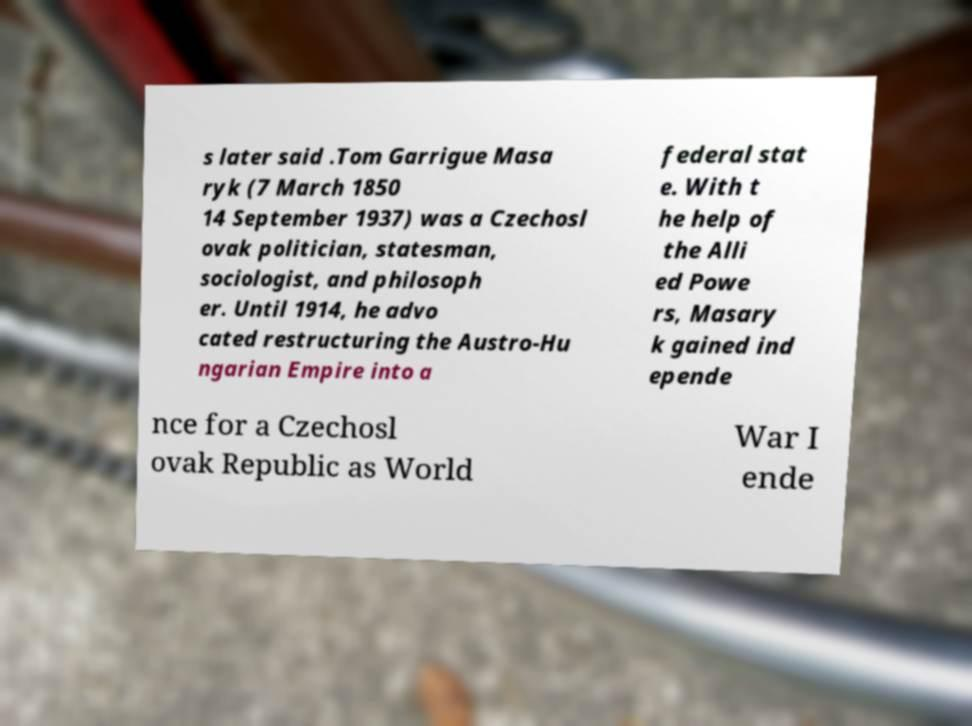There's text embedded in this image that I need extracted. Can you transcribe it verbatim? s later said .Tom Garrigue Masa ryk (7 March 1850 14 September 1937) was a Czechosl ovak politician, statesman, sociologist, and philosoph er. Until 1914, he advo cated restructuring the Austro-Hu ngarian Empire into a federal stat e. With t he help of the Alli ed Powe rs, Masary k gained ind epende nce for a Czechosl ovak Republic as World War I ende 